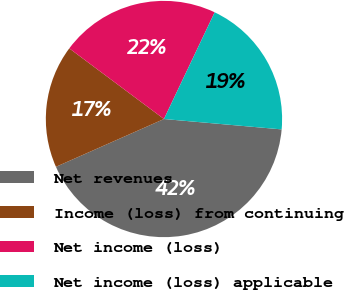<chart> <loc_0><loc_0><loc_500><loc_500><pie_chart><fcel>Net revenues<fcel>Income (loss) from continuing<fcel>Net income (loss)<fcel>Net income (loss) applicable<nl><fcel>41.97%<fcel>16.83%<fcel>21.86%<fcel>19.34%<nl></chart> 